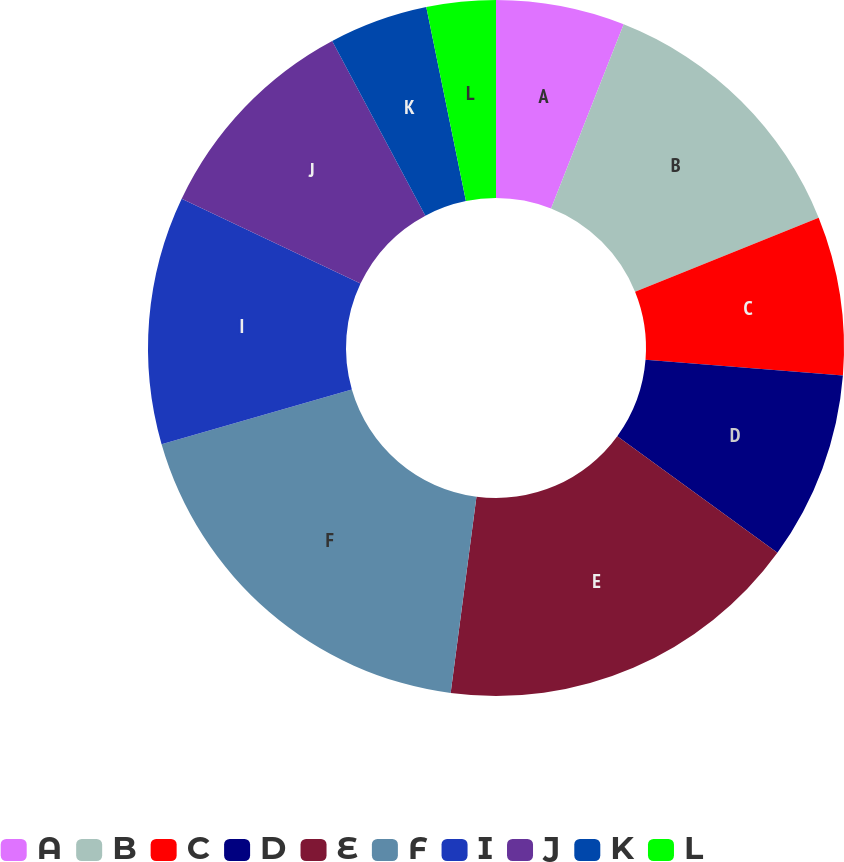Convert chart. <chart><loc_0><loc_0><loc_500><loc_500><pie_chart><fcel>A<fcel>B<fcel>C<fcel>D<fcel>E<fcel>F<fcel>I<fcel>J<fcel>K<fcel>L<nl><fcel>5.98%<fcel>12.91%<fcel>7.37%<fcel>8.75%<fcel>17.07%<fcel>18.46%<fcel>11.52%<fcel>10.14%<fcel>4.59%<fcel>3.21%<nl></chart> 